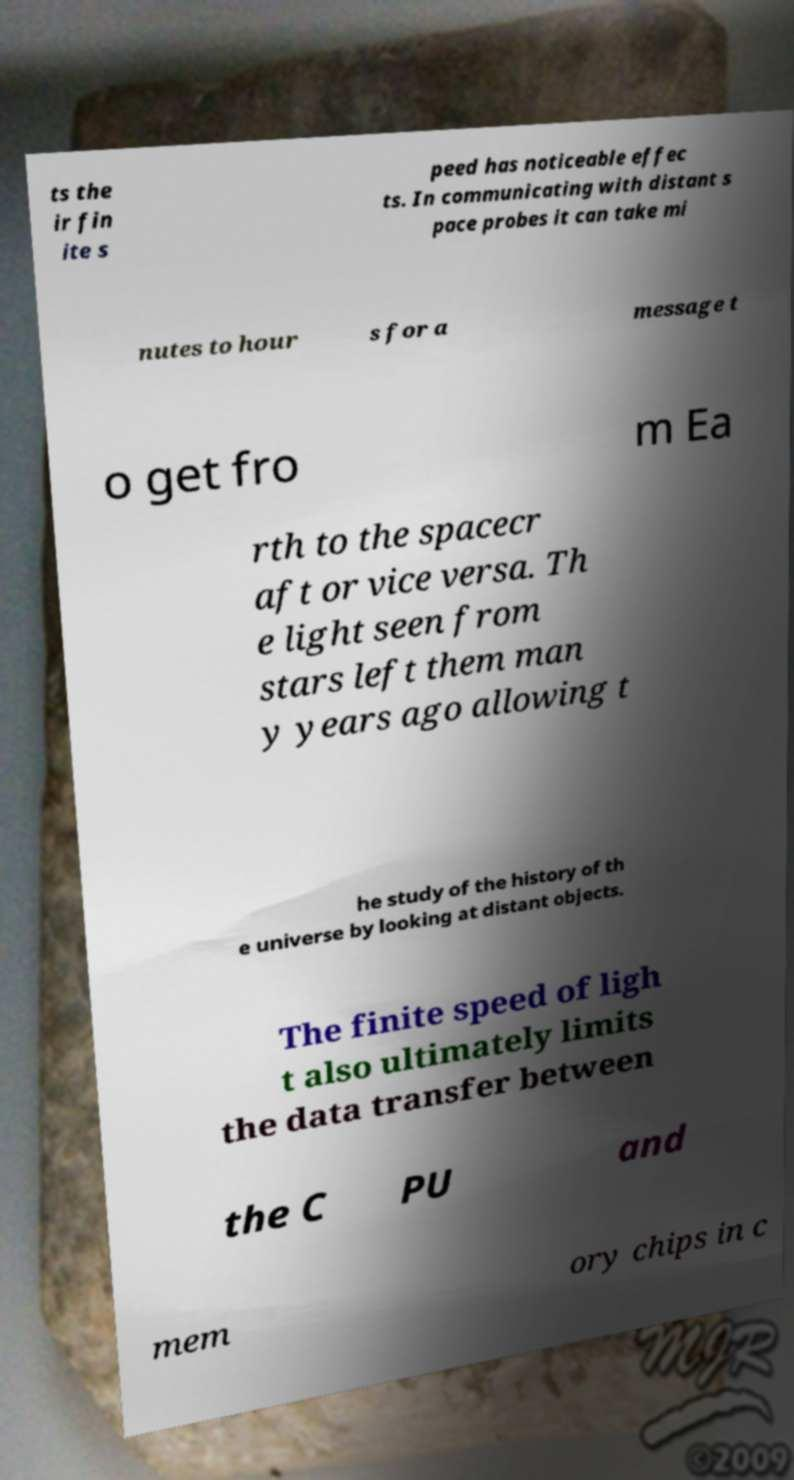Please read and relay the text visible in this image. What does it say? ts the ir fin ite s peed has noticeable effec ts. In communicating with distant s pace probes it can take mi nutes to hour s for a message t o get fro m Ea rth to the spacecr aft or vice versa. Th e light seen from stars left them man y years ago allowing t he study of the history of th e universe by looking at distant objects. The finite speed of ligh t also ultimately limits the data transfer between the C PU and mem ory chips in c 